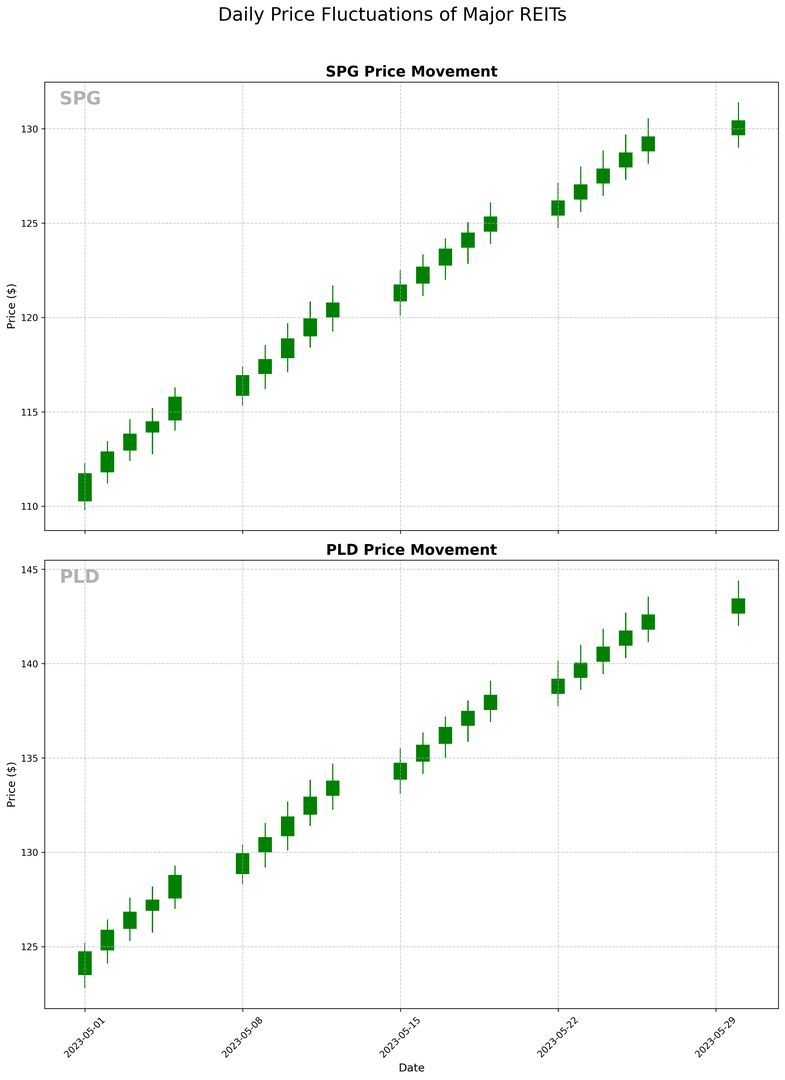what is the highest closing price for SPG? Identify the highest point at which the closing price for SPG reaches on the plot. From the candlestick chart, look at the topmost point of each day's candle (only the body, not the wicks) for SPG and find the highest one. In this case, you will notice that the highest body ends at $130.45 on May 30, 2023.
Answer: $130.45 Which day did PLD have the largest single-day price increase? To find the largest single-day price increase, examine the height of the green candlesticks for PLD. These green candlesticks represent days where Close > Open. The tallest green candlestick will indicate the largest price increase. By observation, May 19 has the tallest green candlestick for PLD, which indicates the highest price increase.
Answer: May 19, 2023 Did SPG experience more days with increases or decreases in price throughout May? Count the number of green candlesticks (increase in price: Close > Open) and red candlesticks (decrease in price: Close < Open) for SPG. By manually counting from the chart, you will find SPG has more green candlesticks than red ones. In specific, there are 15 days where the price increased (green candlesticks) and 5 days where it decreased (red candlesticks).
Answer: More days with increases What is the average closing price for PLD over the last 5 days of May? Extract the closing prices for PLD from the last five days of May: $141.75, $142.60, $143.45. Sum these closing prices and divide by the number of days (3) to get the average. The calculation is: (141.75 + 142.60 + 143.45) / 3 = 142.6.
Answer: 142.60 What trend do you observe in the closing prices of SPG over the entire month? To determine the trend, observe the pattern of closing prices for SPG from the beginning to the end of the month. Generally, the closing prices show an upward trend as they start around $111.75 and gradually make their way up to $130.45 by the end of May. This consistent increase day-to-day indicates an upward trend.
Answer: Upward trend Which REIT has a higher closing price on May 15th? Identify the closing prices of both SPG and PLD on May 15th from the chart. For SPG, the closing price is $121.75, and for PLD, the closing price is $134.75. Comparing these numbers, PLD has a higher closing price on May 15th.
Answer: PLD How does the highest high price for PLD compare to the highest high price for SPG? Extract the highest high prices from the candlesticks for both REITs. For PLD, the highest recorded is $144.40 on May 30, and for SPG, it's $131.40 also on May 30. By comparing, PLD's highest high price is significantly higher than that of SPG's.
Answer: PLD's highest high price is higher Which REIT experienced a more volatile price change range on May 23rd? Identify the high and low prices for both REITs on May 23rd. For SPG, the range is between $128 and $125.60 (range = $2.40). For PLD, the range is between $141 and $138.60 (range = $2.40). Both REITs experienced the same range of price change on this day.
Answer: Both have the same range How many times did SPG's daily low price fall below $120? Visually scan the chart for SPG and count the number of days where the bottom of the candlestick's wick is lower than $120. Observing the chart, you will see the days: May 1st, May 2nd, May 3rd, May 4th, May 5th, May 8th, May 9th, May 10th, May 11th, and May 12th. Altogether, there are 10 days where SPG's daily low price fell below $120.
Answer: 10 times 